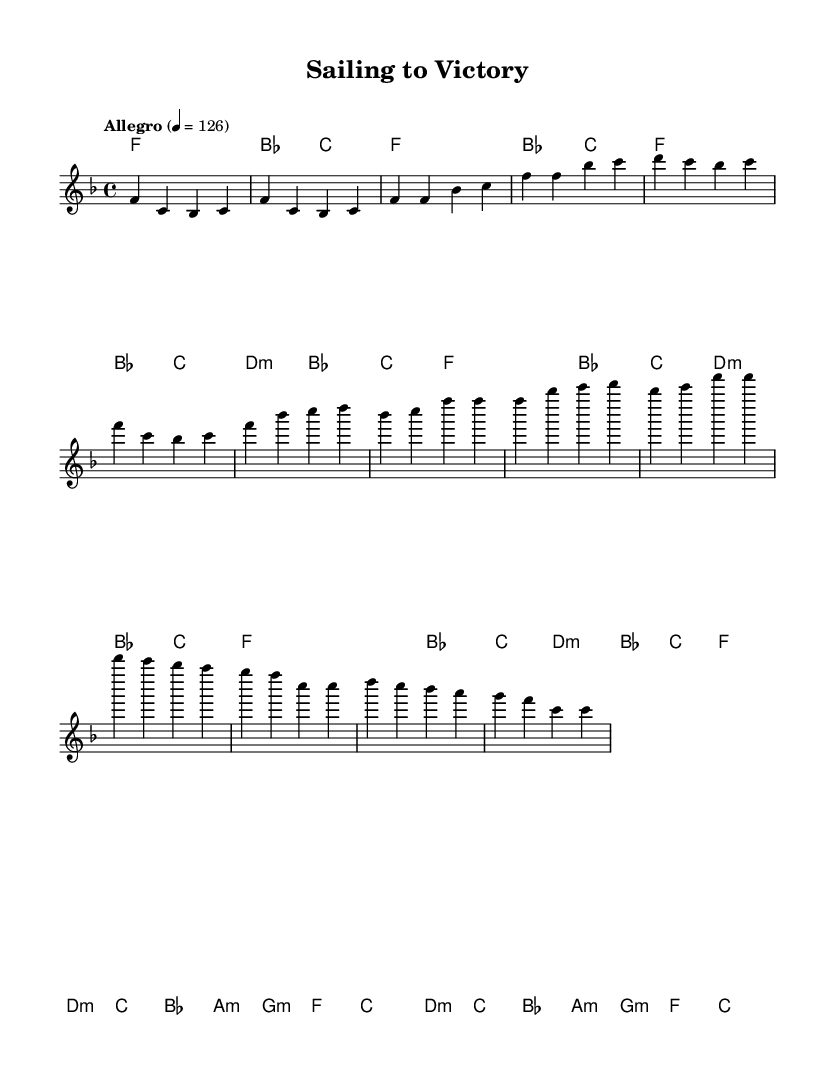What is the key signature of this music? The key signature shown at the beginning of the score indicates that the music is in F major, which has one flat (B flat).
Answer: F major What is the time signature of this piece? The time signature is indicated at the beginning of the score, showing that there are four beats per measure, which is represented as 4/4.
Answer: 4/4 What is the tempo marking? The tempo marking at the beginning of the score reads "Allegro" with a metronome marking of 126 beats per minute, indicating a fast-paced tempo.
Answer: Allegro, 126 How many measures are in the chorus? By counting the sections labeled in the score, the chorus has a total of eight measures, marked by the music under the chorus section.
Answer: 8 What is the chord for the bridge section? The bridge section of the music shows various chords being played, with d minor, c major, b flat major, a minor, g major, and f major chords all appearing as part of the harmonic structure.
Answer: d minor, c major, b flat major, a minor, g major, f major What overall theme does this piece celebrate? Considering the title “Sailing to Victory” and the upbeat melodies, the overall theme of the music is aligned with celebrating athletic achievements and personal triumphs, especially in a sailing context.
Answer: Athletic achievements What characterizes the musical structure of soul music in this piece? The structure includes repetitive verses and choruses that convey an uplifting and expressive mood, characteristic of soul music, utilizing rhythmic and soulful melodies to inspire feelings of joy and success.
Answer: Repetitive verses and choruses 